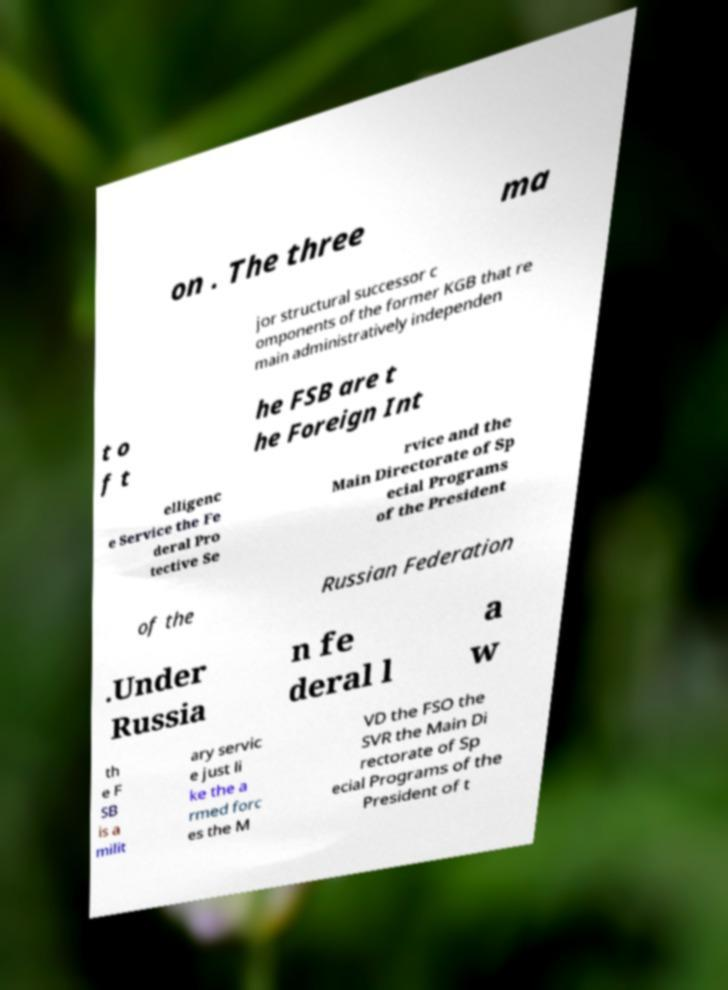Can you accurately transcribe the text from the provided image for me? on . The three ma jor structural successor c omponents of the former KGB that re main administratively independen t o f t he FSB are t he Foreign Int elligenc e Service the Fe deral Pro tective Se rvice and the Main Directorate of Sp ecial Programs of the President of the Russian Federation .Under Russia n fe deral l a w th e F SB is a milit ary servic e just li ke the a rmed forc es the M VD the FSO the SVR the Main Di rectorate of Sp ecial Programs of the President of t 